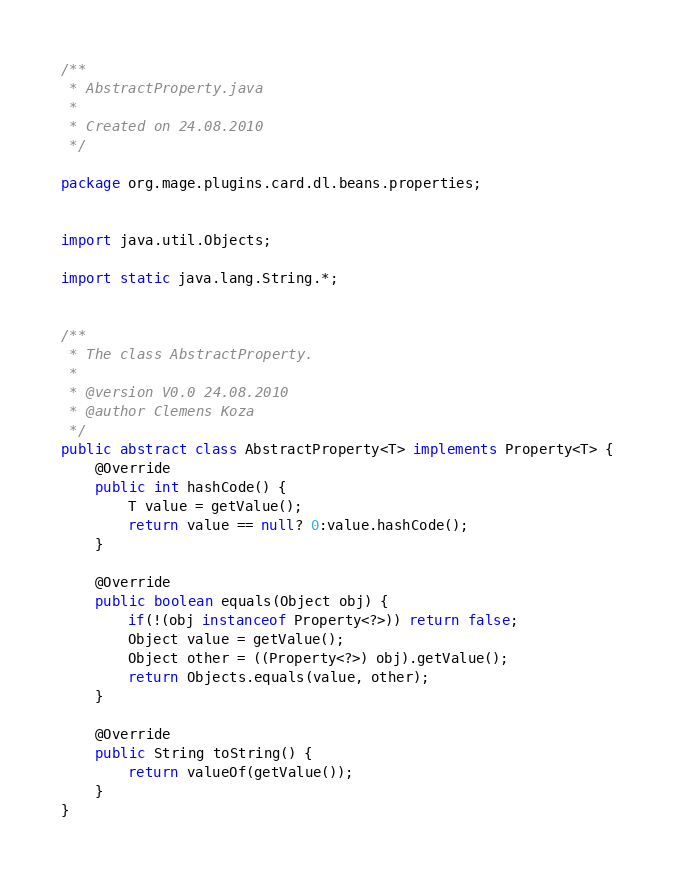Convert code to text. <code><loc_0><loc_0><loc_500><loc_500><_Java_>/**
 * AbstractProperty.java
 * 
 * Created on 24.08.2010
 */

package org.mage.plugins.card.dl.beans.properties;


import java.util.Objects;

import static java.lang.String.*;


/**
 * The class AbstractProperty.
 * 
 * @version V0.0 24.08.2010
 * @author Clemens Koza
 */
public abstract class AbstractProperty<T> implements Property<T> {
    @Override
    public int hashCode() {
        T value = getValue();
        return value == null? 0:value.hashCode();
    }

    @Override
    public boolean equals(Object obj) {
        if(!(obj instanceof Property<?>)) return false;
        Object value = getValue();
        Object other = ((Property<?>) obj).getValue();
        return Objects.equals(value, other);
    }

    @Override
    public String toString() {
        return valueOf(getValue());
    }
}
</code> 